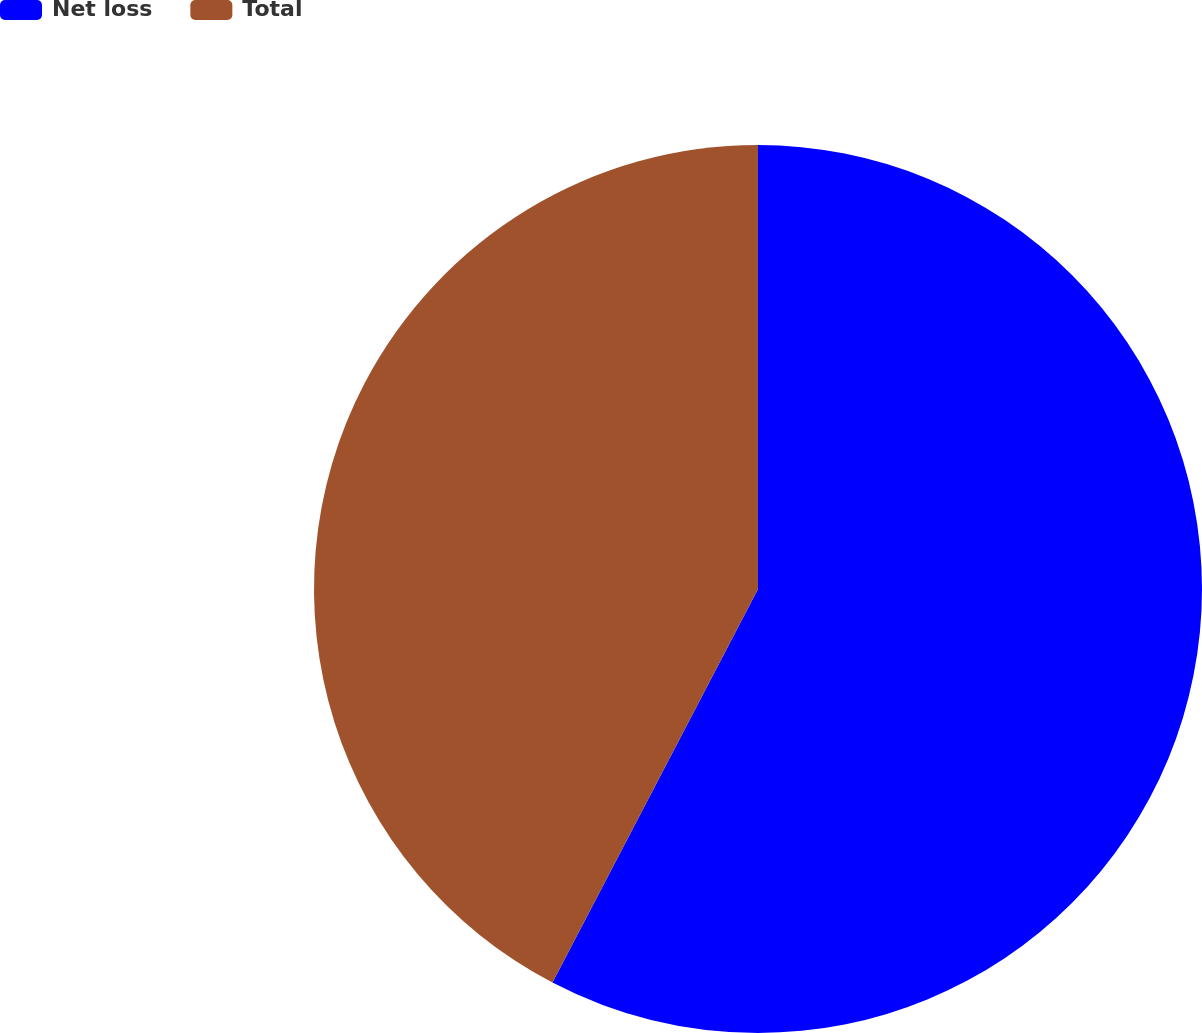<chart> <loc_0><loc_0><loc_500><loc_500><pie_chart><fcel>Net loss<fcel>Total<nl><fcel>57.66%<fcel>42.34%<nl></chart> 